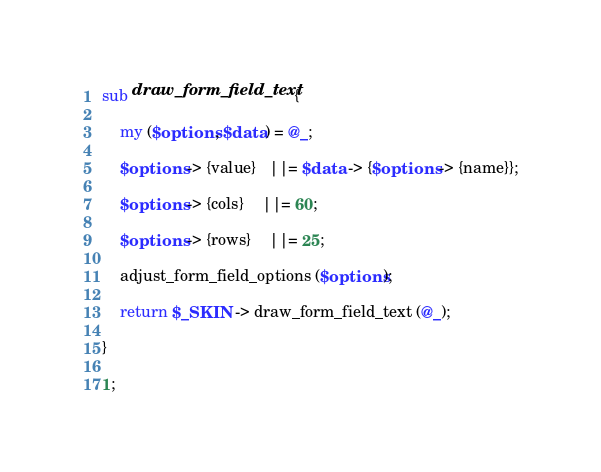Convert code to text. <code><loc_0><loc_0><loc_500><loc_500><_Perl_>sub draw_form_field_text {

	my ($options, $data) = @_;
	
	$options -> {value}   ||= $data -> {$options -> {name}};

	$options -> {cols}    ||= 60;
	
	$options -> {rows}    ||= 25;
	
	adjust_form_field_options ($options);
	
	return $_SKIN -> draw_form_field_text (@_);

}

1;</code> 